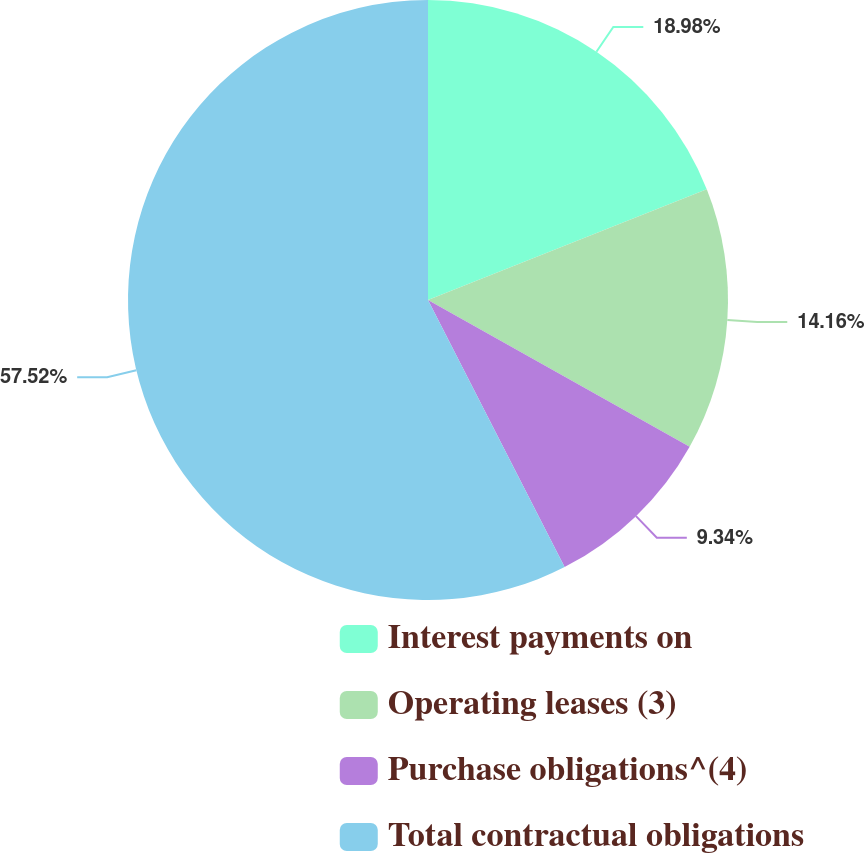Convert chart to OTSL. <chart><loc_0><loc_0><loc_500><loc_500><pie_chart><fcel>Interest payments on<fcel>Operating leases (3)<fcel>Purchase obligations^(4)<fcel>Total contractual obligations<nl><fcel>18.98%<fcel>14.16%<fcel>9.34%<fcel>57.53%<nl></chart> 